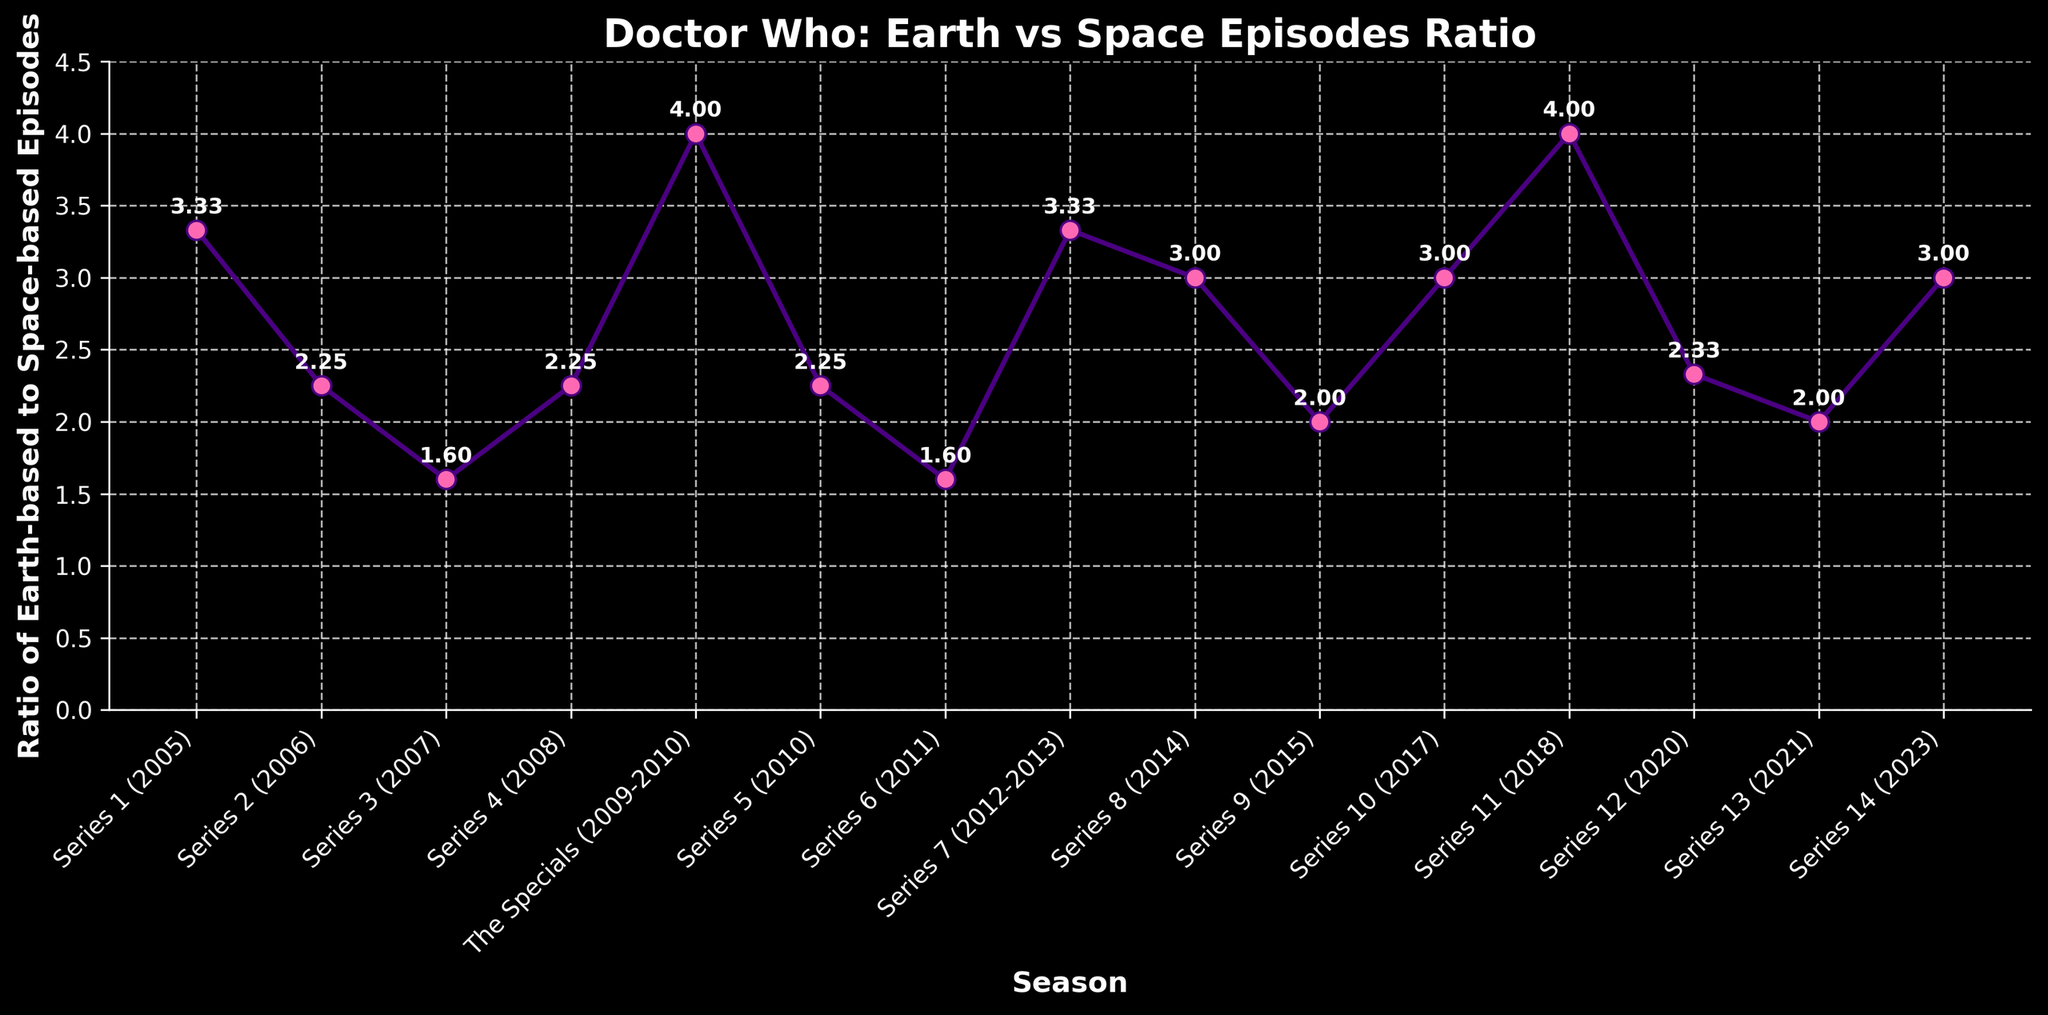What is the ratio of Earth-based to space-based episodes in Series 1 (2005)? The line chart annotates each point with the ratios. For Series 1 (2005), we can directly read the ratio from the annotation next to the marker on the line representing this series.
Answer: 3.33 Which series has the highest ratio of Earth-based to space-based episodes? The line chart displays the ratios for each series, and the highest point on the plot shows the series with the highest ratio. The highest ratio is annotated as 4.00 for the Specials (2009-2010) and Series 11 (2018).
Answer: The Specials (2009-2010) and Series 11 (2018) What is the average ratio of Earth-based to space-based episodes across all series? To find the average, sum all the ratios and divide by the number of series. Sum the ratios given: \(3.33 + 2.25 + 1.60 + 2.25 + 4.00 + 2.25 + 1.60 + 3.33 + 3.00 + 2.00 + 3.00 + 4.00 + 2.33 + 2.00 + 3.00 = 40.94\). There are 15 series, so the average is \( \frac{40.94}{15} = 2.73 \).
Answer: 2.73 Which series had a higher ratio of Earth-based to space-based episodes, Series 7 (2012-2013) or Series 10 (2017)? Compare the annotated ratios for Series 7 and Series 10. Series 7 has a ratio of 3.33, and Series 10 has a ratio of 3.00.
Answer: Series 7 (2012-2013) How does the ratio in Series 6 (2011) compare to Series 9 (2015)? By looking at the annotations, Series 6 has a ratio of 1.60, and Series 9 has a ratio of 2.00. Series 9 has a higher ratio than Series 6.
Answer: Series 9 (2015) What is the difference in the ratio between Series 8 (2014) and Series 12 (2020)? Subtract the ratio of Series 12 from Series 8. From the annotations, Series 8 has a ratio of 3.00, and Series 12 has a ratio of 2.33. The difference is \(3.00 - 2.33 = 0.67\).
Answer: 0.67 Which series has the smallest ratio of Earth-based to space-based episodes, and what is that ratio? Identify the lowest point on the plot and read the annotated ratio. The smallest ratio on the plot is annotated as 1.60, which occurs in Series 3 (2007) and Series 6 (2011).
Answer: Series 3 (2007) and Series 6 (2011), 1.60 